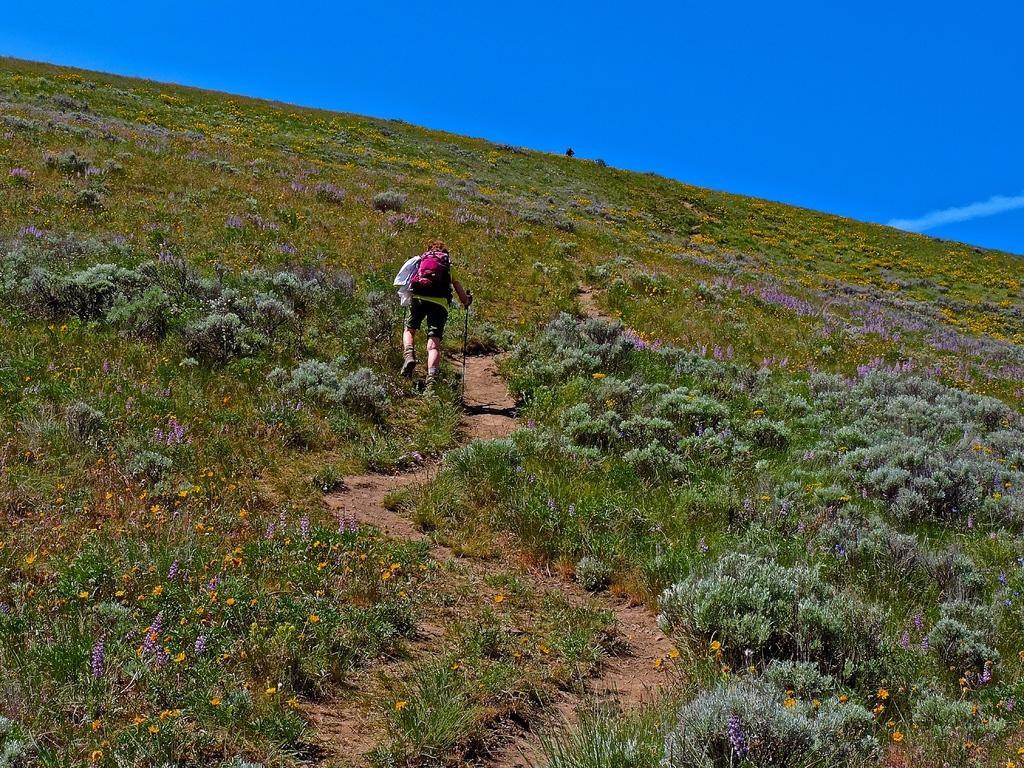Describe this image in one or two sentences. A person is trekking wearing a bag and holding a stick. There is grass, flowers on the hill. There is sky at the top. 